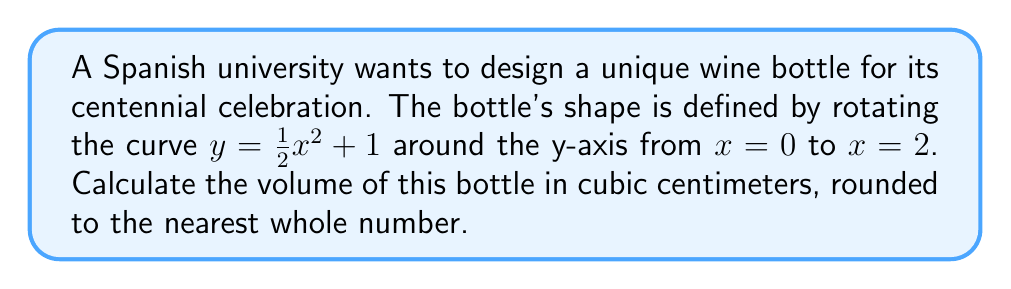Solve this math problem. To solve this problem, we'll use the method of integration to find the volume of a solid of revolution. The steps are as follows:

1) The volume of a solid of revolution around the y-axis is given by the formula:

   $$V = \pi \int_a^b [f^{-1}(y)]^2 dy$$

   where $f^{-1}(y)$ is the inverse function of $y = f(x)$.

2) Our function is $y = \frac{1}{2}x^2 + 1$. We need to solve this for x:

   $$x = \sqrt{2(y-1)}$$

3) The limits of integration will be from $y = 1$ (when $x = 0$) to $y = 3$ (when $x = 2$).

4) Substituting into our volume formula:

   $$V = \pi \int_1^3 [2(y-1)] dy$$

5) Simplify inside the integral:

   $$V = 2\pi \int_1^3 (y-1) dy$$

6) Integrate:

   $$V = 2\pi [\frac{1}{2}y^2 - y]_1^3$$

7) Evaluate the definite integral:

   $$V = 2\pi [(\frac{1}{2}(3)^2 - 3) - (\frac{1}{2}(1)^2 - 1)]$$
   $$V = 2\pi [\frac{9}{2} - 3 - \frac{1}{2} + 1]$$
   $$V = 2\pi [3]$$
   $$V = 6\pi$$

8) Convert to cubic centimeters (1 π ≈ 3.14159):

   $$V ≈ 18.85 \text{ cm}^3$$

9) Rounding to the nearest whole number:

   $$V ≈ 19 \text{ cm}^3$$
Answer: 19 cm³ 